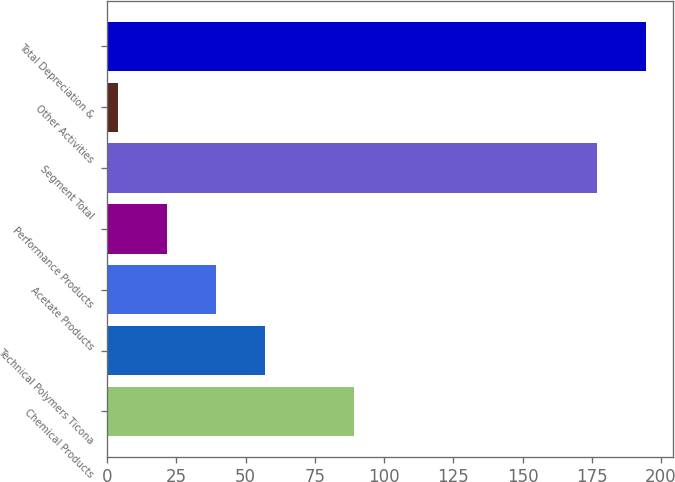Convert chart. <chart><loc_0><loc_0><loc_500><loc_500><bar_chart><fcel>Chemical Products<fcel>Technical Polymers Ticona<fcel>Acetate Products<fcel>Performance Products<fcel>Segment Total<fcel>Other Activities<fcel>Total Depreciation &<nl><fcel>89<fcel>57.1<fcel>39.4<fcel>21.7<fcel>177<fcel>4<fcel>194.7<nl></chart> 